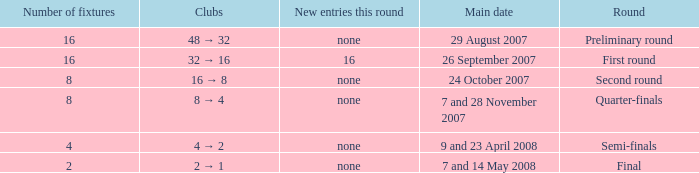What is the Clubs when there are 4 for the number of fixtures? 4 → 2. 